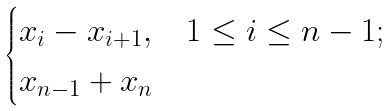<formula> <loc_0><loc_0><loc_500><loc_500>\begin{cases} x _ { i } - x _ { i + 1 } , & 1 \leq i \leq n - 1 ; \\ x _ { n - 1 } + x _ { n } \end{cases}</formula> 